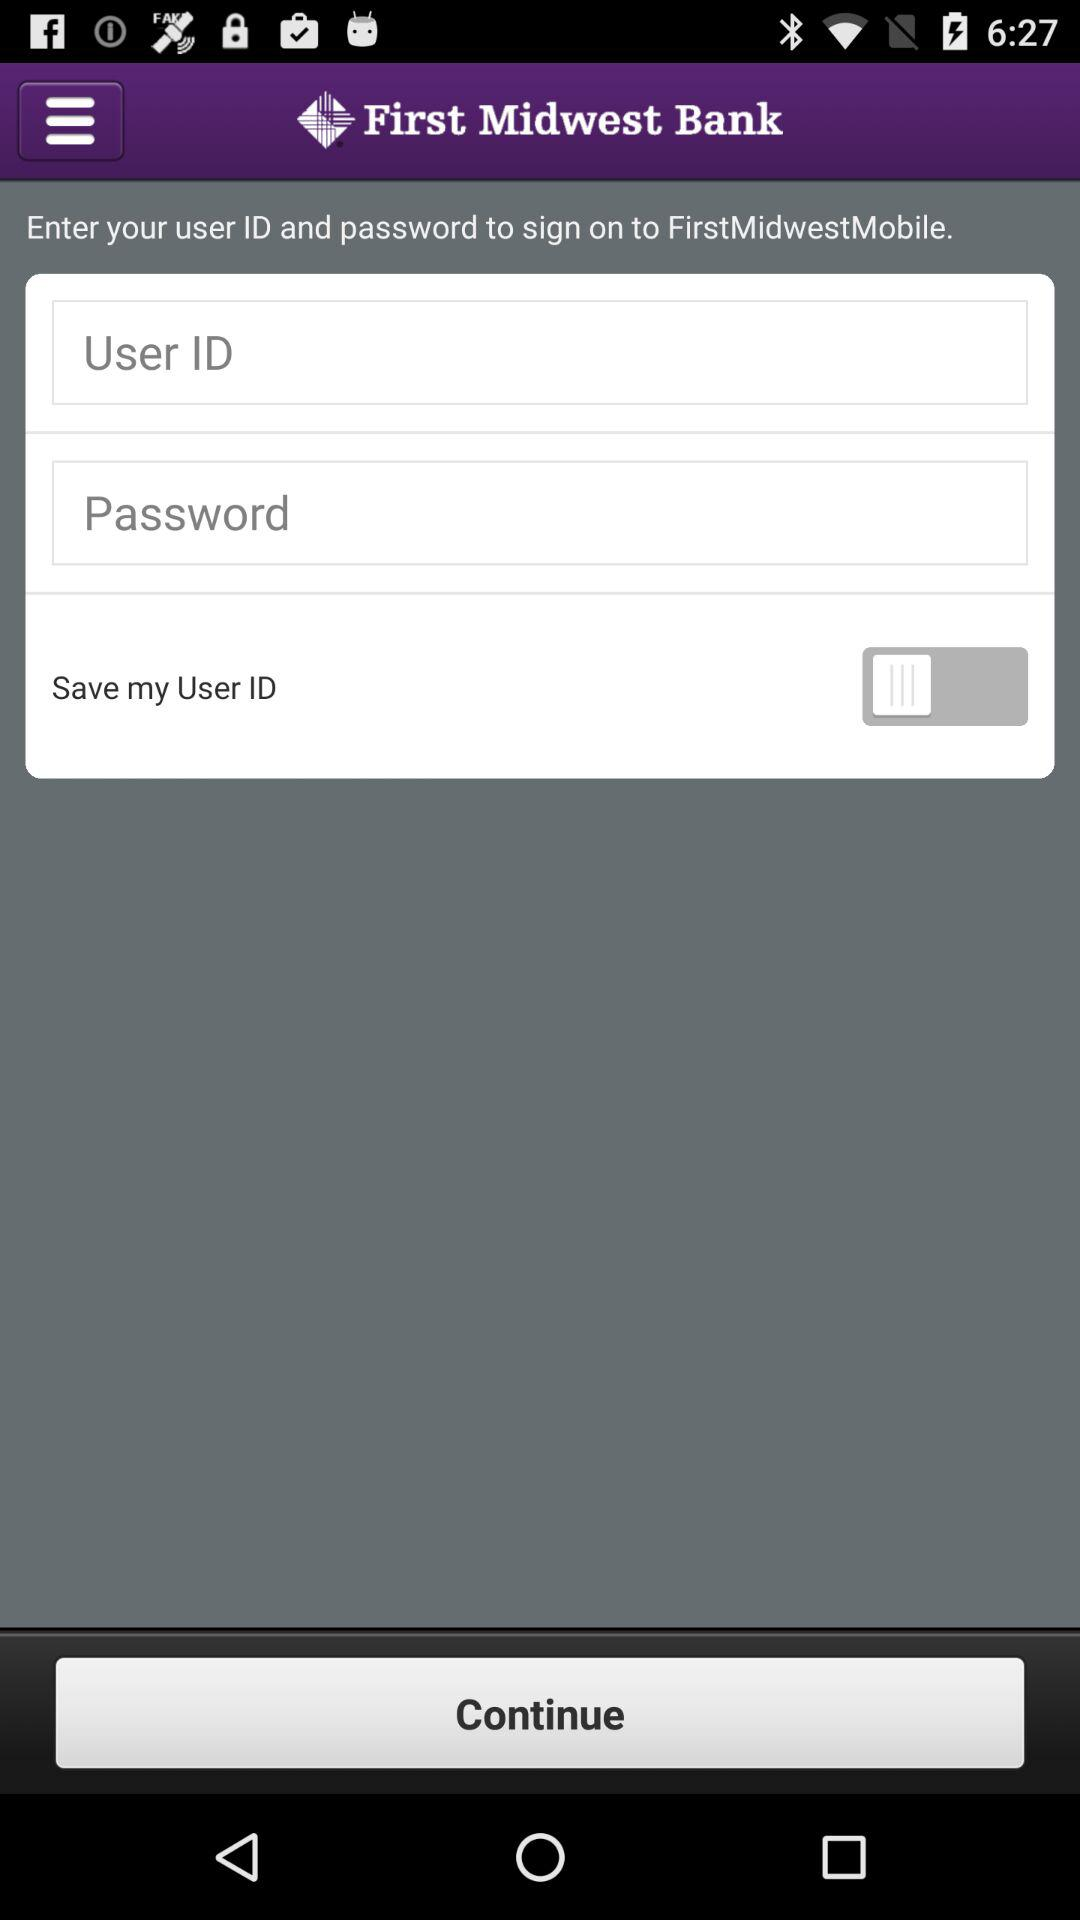What is the application name? The application name is "First Midwest Bank". 